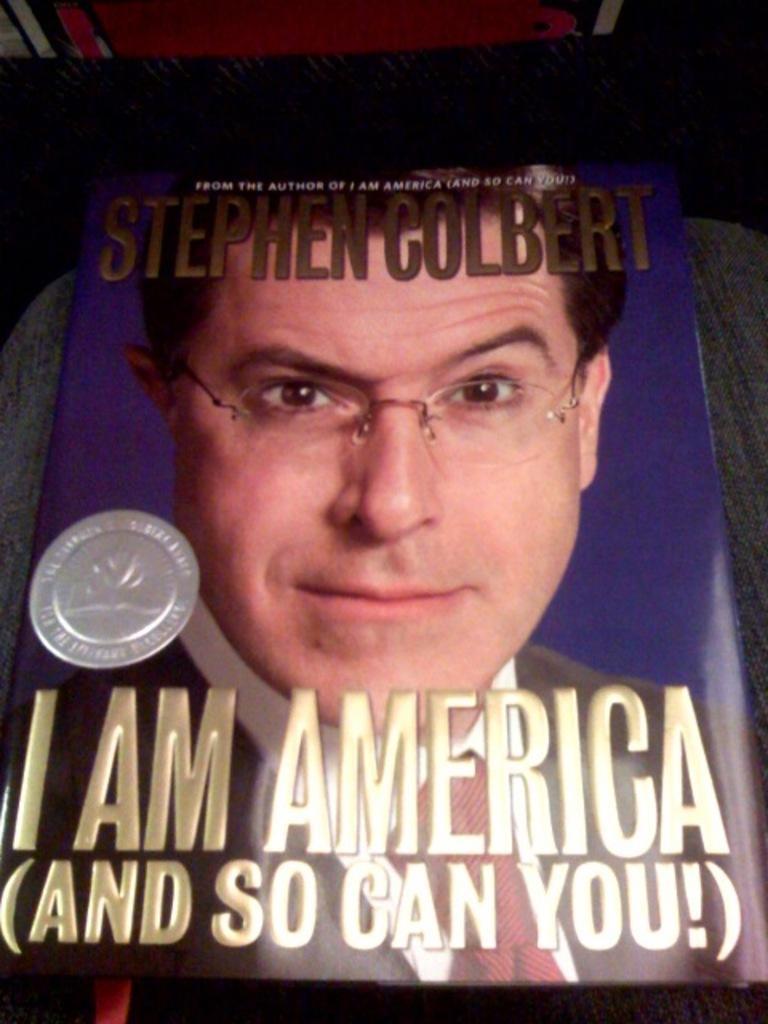How would you summarize this image in a sentence or two? There is a book with an image of a person wearing specs. And something is written on the book. And the book is on a surface. 